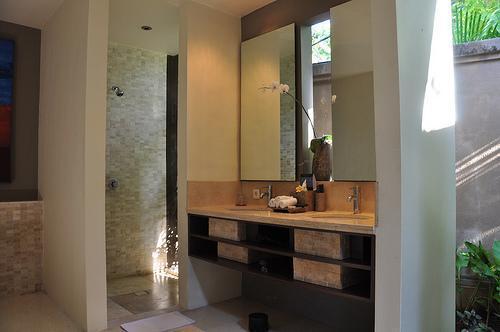How many sinks are in the picture?
Give a very brief answer. 2. 